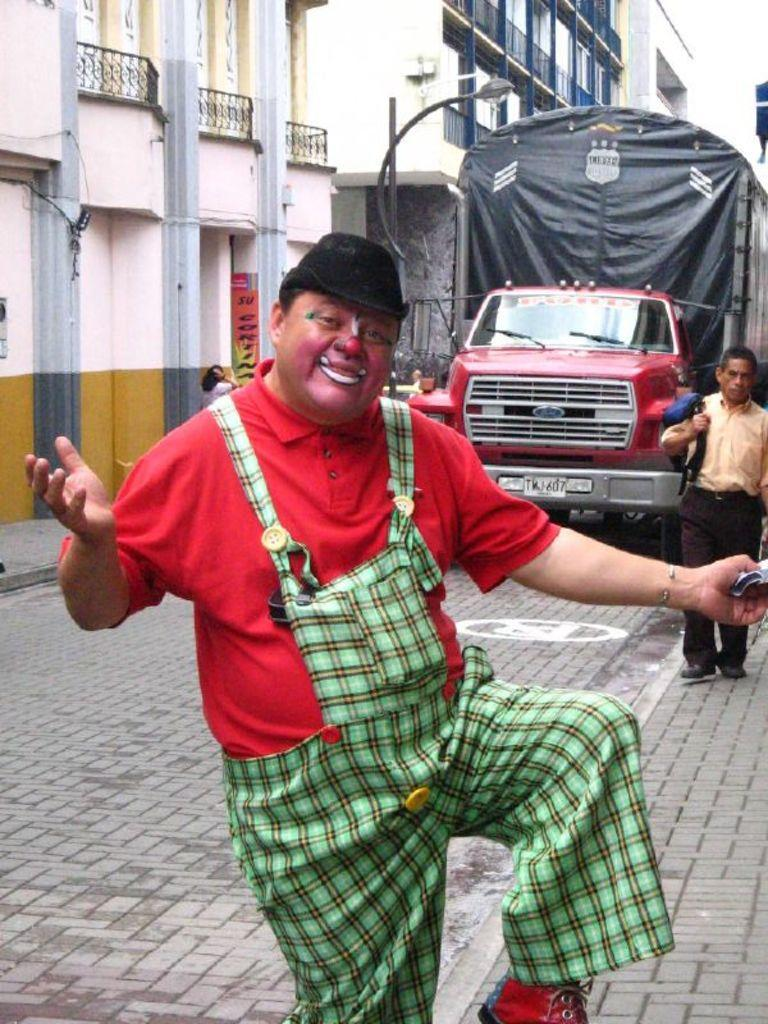Who or what can be seen in the image? There are people in the image. What type of structures are visible in the image? There are buildings in the image. Is there any mode of transportation present in the image? Yes, there is a vehicle in the image. What is the surface that the people, buildings, and vehicle are standing on or near? The ground is visible in the image. Are there any additional objects or signs in the image? Yes, there is a poster and a pole in the image. What type of canvas is being used by the society in the image? There is no canvas or reference to a society in the image; it features people, buildings, a vehicle, the ground, a poster, and a pole. 